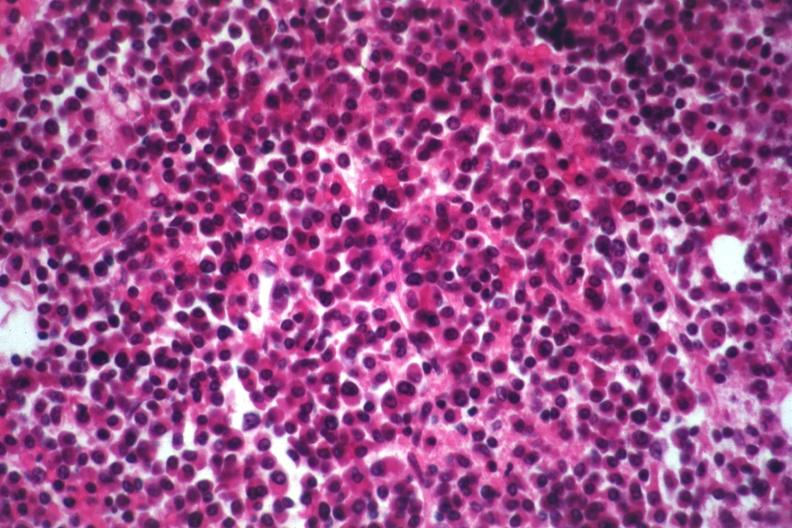s myocardial infarct present?
Answer the question using a single word or phrase. No 